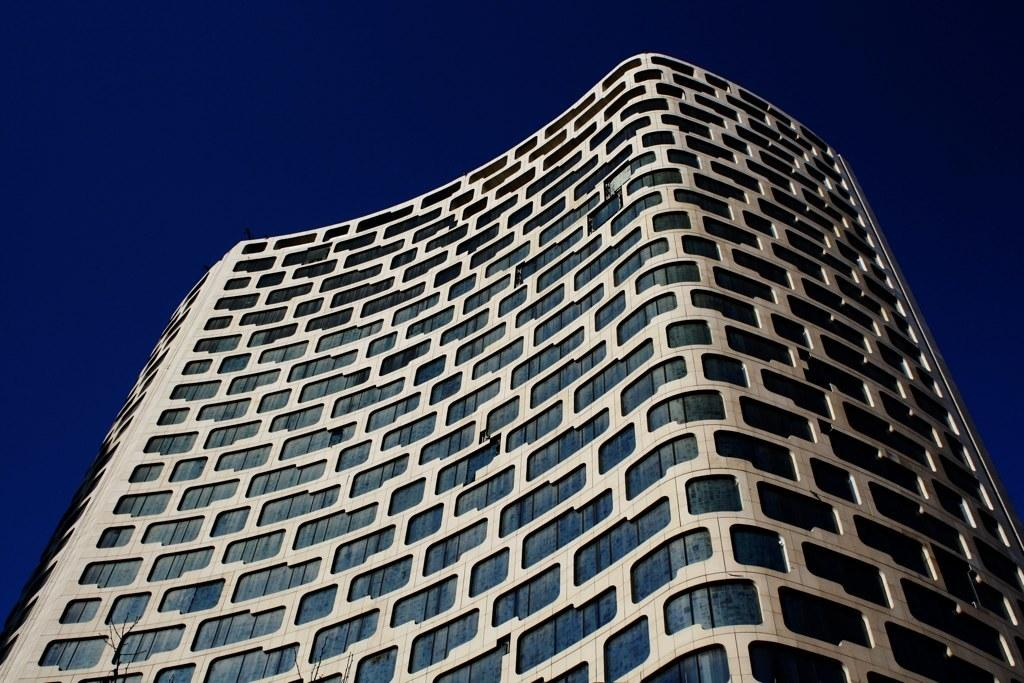What is the main structure in the image? There is a tower in the image. What can be seen at the top of the image? The sky is visible at the top of the image. What shape is the river in the image? There is no river present in the image. What is the color of the moon in the image? There is no moon present in the image. 